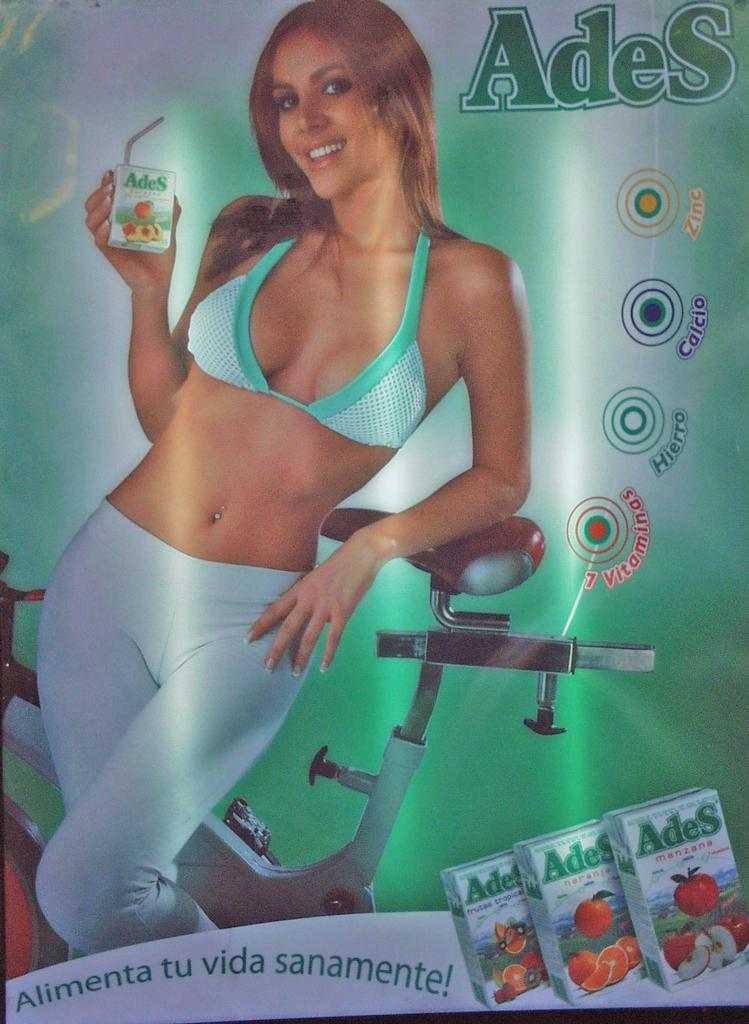Who is present in the image? There is a woman in the image. What type of blade is the woman using to cut the border in the image? There is no blade or border present in the image; it only features a woman. 